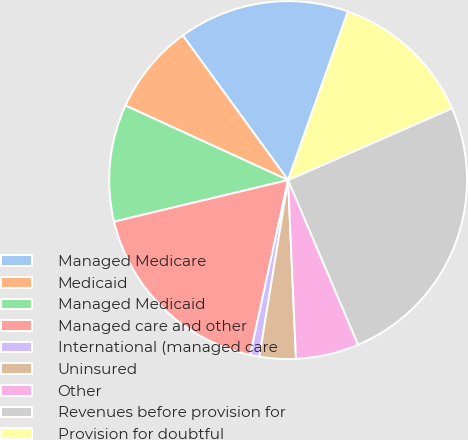Convert chart. <chart><loc_0><loc_0><loc_500><loc_500><pie_chart><fcel>Managed Medicare<fcel>Medicaid<fcel>Managed Medicaid<fcel>Managed care and other<fcel>International (managed care<fcel>Uninsured<fcel>Other<fcel>Revenues before provision for<fcel>Provision for doubtful<nl><fcel>15.44%<fcel>8.14%<fcel>10.57%<fcel>17.87%<fcel>0.83%<fcel>3.27%<fcel>5.7%<fcel>25.17%<fcel>13.0%<nl></chart> 